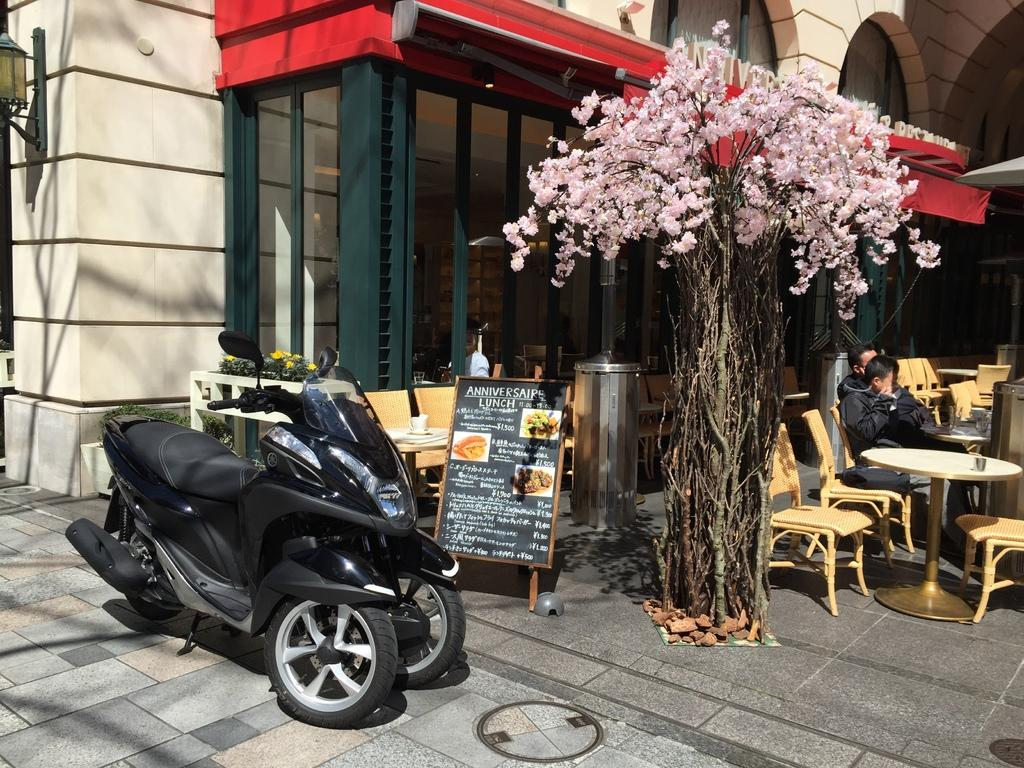What type of plant is visible in the image? There is a plant in the image, but the specific type cannot be determined from the provided facts. What is the other main object in the image besides the plant? There is a bike in the image. What other objects can be seen in the image? There is a board, many chairs, and a table in the image. What are the two persons in the image doing? The two persons are sitting on chairs in the image. What type of structure is the image of? The image is of a building. What type of copper structure can be seen in the image? There is no copper structure present in the image. Can you see any bones in the image? There are no bones visible in the image. 